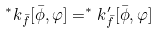Convert formula to latex. <formula><loc_0><loc_0><loc_500><loc_500>^ { * } k _ { \bar { f } } [ \bar { \phi } , \varphi ] = ^ { * } k ^ { \prime } _ { \bar { f } } [ \bar { \phi } , \varphi ]</formula> 